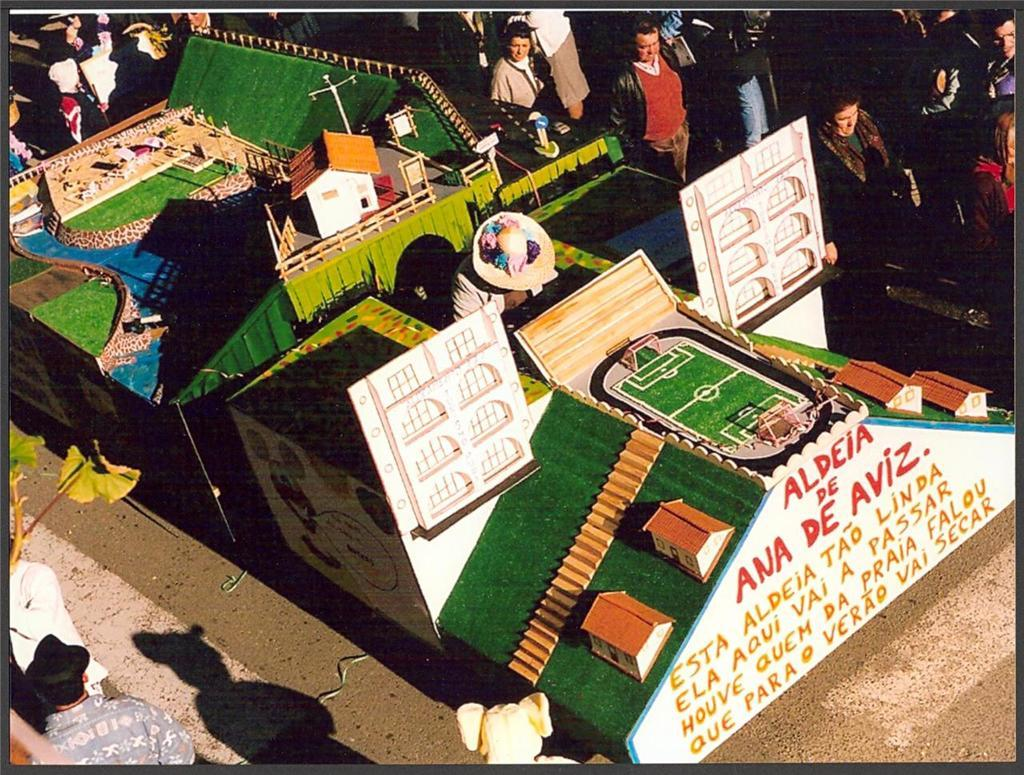What type of structures are depicted in the image? There are miniature buildings in the image. What else can be seen in the image besides the buildings? There are poles, fencing, boards, and other objects in the image. Are there any people present in the image? Yes, there are people in the image. What type of rock is being used as a legal counsel in the image? There is no rock or lawyer present in the image. How much sugar is being used to sweeten the people in the image? There is no sugar or indication of sweetening in the image; it features miniature buildings, poles, fencing, boards, and people. 